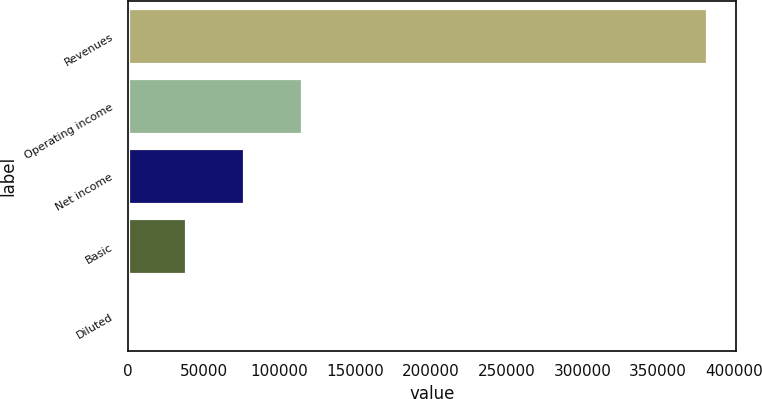<chart> <loc_0><loc_0><loc_500><loc_500><bar_chart><fcel>Revenues<fcel>Operating income<fcel>Net income<fcel>Basic<fcel>Diluted<nl><fcel>382304<fcel>114691<fcel>76461.1<fcel>38230.7<fcel>0.37<nl></chart> 